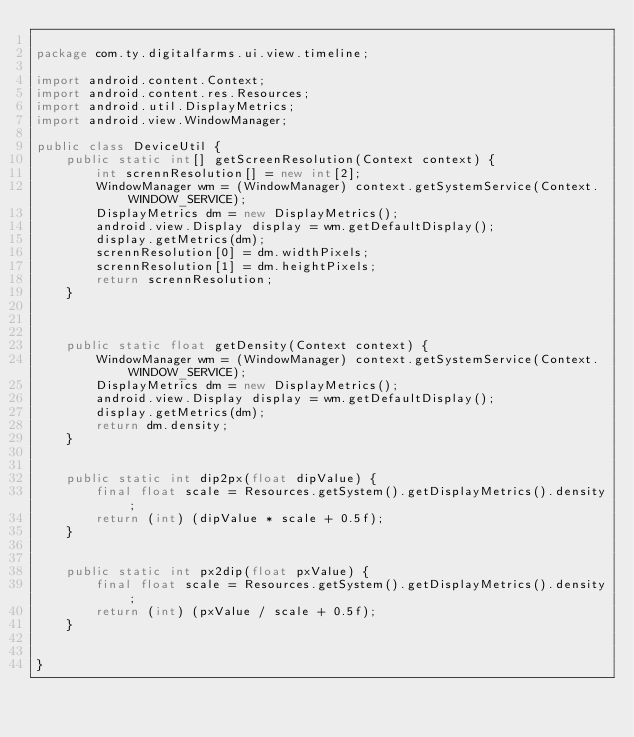<code> <loc_0><loc_0><loc_500><loc_500><_Java_>
package com.ty.digitalfarms.ui.view.timeline;

import android.content.Context;
import android.content.res.Resources;
import android.util.DisplayMetrics;
import android.view.WindowManager;

public class DeviceUtil {
    public static int[] getScreenResolution(Context context) {
        int scrennResolution[] = new int[2];
        WindowManager wm = (WindowManager) context.getSystemService(Context.WINDOW_SERVICE);
        DisplayMetrics dm = new DisplayMetrics();
        android.view.Display display = wm.getDefaultDisplay();
        display.getMetrics(dm);
        scrennResolution[0] = dm.widthPixels;
        scrennResolution[1] = dm.heightPixels;
        return scrennResolution;
    }



    public static float getDensity(Context context) {
        WindowManager wm = (WindowManager) context.getSystemService(Context.WINDOW_SERVICE);
        DisplayMetrics dm = new DisplayMetrics();
        android.view.Display display = wm.getDefaultDisplay();
        display.getMetrics(dm);
        return dm.density;
    }


    public static int dip2px(float dipValue) {
        final float scale = Resources.getSystem().getDisplayMetrics().density;
        return (int) (dipValue * scale + 0.5f);
    }


    public static int px2dip(float pxValue) {
        final float scale = Resources.getSystem().getDisplayMetrics().density;
        return (int) (pxValue / scale + 0.5f);
    }


}
</code> 